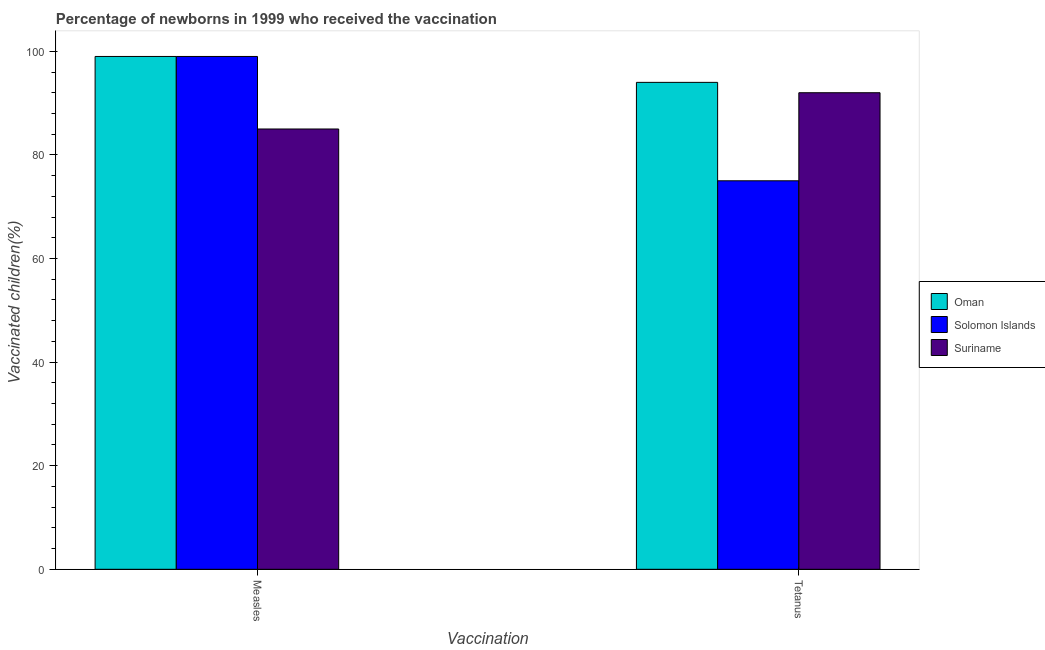How many different coloured bars are there?
Make the answer very short. 3. Are the number of bars on each tick of the X-axis equal?
Give a very brief answer. Yes. How many bars are there on the 2nd tick from the right?
Give a very brief answer. 3. What is the label of the 2nd group of bars from the left?
Make the answer very short. Tetanus. What is the percentage of newborns who received vaccination for tetanus in Oman?
Provide a succinct answer. 94. Across all countries, what is the maximum percentage of newborns who received vaccination for measles?
Provide a short and direct response. 99. Across all countries, what is the minimum percentage of newborns who received vaccination for tetanus?
Offer a very short reply. 75. In which country was the percentage of newborns who received vaccination for measles maximum?
Your answer should be very brief. Oman. In which country was the percentage of newborns who received vaccination for tetanus minimum?
Offer a terse response. Solomon Islands. What is the total percentage of newborns who received vaccination for tetanus in the graph?
Your answer should be compact. 261. What is the difference between the percentage of newborns who received vaccination for tetanus in Suriname and that in Oman?
Your answer should be very brief. -2. What is the difference between the percentage of newborns who received vaccination for tetanus in Oman and the percentage of newborns who received vaccination for measles in Solomon Islands?
Offer a very short reply. -5. What is the average percentage of newborns who received vaccination for measles per country?
Your response must be concise. 94.33. What is the difference between the percentage of newborns who received vaccination for measles and percentage of newborns who received vaccination for tetanus in Solomon Islands?
Make the answer very short. 24. In how many countries, is the percentage of newborns who received vaccination for tetanus greater than 16 %?
Your answer should be compact. 3. What is the ratio of the percentage of newborns who received vaccination for tetanus in Oman to that in Solomon Islands?
Give a very brief answer. 1.25. What does the 2nd bar from the left in Measles represents?
Ensure brevity in your answer.  Solomon Islands. What does the 3rd bar from the right in Tetanus represents?
Your answer should be compact. Oman. Are all the bars in the graph horizontal?
Ensure brevity in your answer.  No. How many countries are there in the graph?
Give a very brief answer. 3. What is the difference between two consecutive major ticks on the Y-axis?
Your answer should be compact. 20. Does the graph contain any zero values?
Your answer should be very brief. No. How many legend labels are there?
Ensure brevity in your answer.  3. How are the legend labels stacked?
Make the answer very short. Vertical. What is the title of the graph?
Provide a succinct answer. Percentage of newborns in 1999 who received the vaccination. What is the label or title of the X-axis?
Provide a short and direct response. Vaccination. What is the label or title of the Y-axis?
Your response must be concise. Vaccinated children(%)
. What is the Vaccinated children(%)
 in Oman in Measles?
Make the answer very short. 99. What is the Vaccinated children(%)
 of Solomon Islands in Measles?
Offer a very short reply. 99. What is the Vaccinated children(%)
 in Oman in Tetanus?
Your answer should be very brief. 94. What is the Vaccinated children(%)
 of Suriname in Tetanus?
Offer a terse response. 92. Across all Vaccination, what is the maximum Vaccinated children(%)
 in Oman?
Give a very brief answer. 99. Across all Vaccination, what is the maximum Vaccinated children(%)
 in Solomon Islands?
Your answer should be compact. 99. Across all Vaccination, what is the maximum Vaccinated children(%)
 in Suriname?
Your answer should be compact. 92. Across all Vaccination, what is the minimum Vaccinated children(%)
 of Oman?
Ensure brevity in your answer.  94. Across all Vaccination, what is the minimum Vaccinated children(%)
 in Suriname?
Your answer should be compact. 85. What is the total Vaccinated children(%)
 of Oman in the graph?
Your answer should be very brief. 193. What is the total Vaccinated children(%)
 of Solomon Islands in the graph?
Ensure brevity in your answer.  174. What is the total Vaccinated children(%)
 of Suriname in the graph?
Provide a short and direct response. 177. What is the difference between the Vaccinated children(%)
 in Suriname in Measles and that in Tetanus?
Provide a succinct answer. -7. What is the difference between the Vaccinated children(%)
 in Oman in Measles and the Vaccinated children(%)
 in Suriname in Tetanus?
Provide a succinct answer. 7. What is the difference between the Vaccinated children(%)
 in Solomon Islands in Measles and the Vaccinated children(%)
 in Suriname in Tetanus?
Your response must be concise. 7. What is the average Vaccinated children(%)
 of Oman per Vaccination?
Provide a succinct answer. 96.5. What is the average Vaccinated children(%)
 in Solomon Islands per Vaccination?
Offer a terse response. 87. What is the average Vaccinated children(%)
 of Suriname per Vaccination?
Your answer should be very brief. 88.5. What is the difference between the Vaccinated children(%)
 of Oman and Vaccinated children(%)
 of Solomon Islands in Measles?
Give a very brief answer. 0. What is the difference between the Vaccinated children(%)
 in Oman and Vaccinated children(%)
 in Suriname in Tetanus?
Your answer should be very brief. 2. What is the ratio of the Vaccinated children(%)
 of Oman in Measles to that in Tetanus?
Offer a very short reply. 1.05. What is the ratio of the Vaccinated children(%)
 of Solomon Islands in Measles to that in Tetanus?
Ensure brevity in your answer.  1.32. What is the ratio of the Vaccinated children(%)
 of Suriname in Measles to that in Tetanus?
Offer a terse response. 0.92. What is the difference between the highest and the second highest Vaccinated children(%)
 in Solomon Islands?
Your answer should be very brief. 24. What is the difference between the highest and the second highest Vaccinated children(%)
 in Suriname?
Provide a short and direct response. 7. What is the difference between the highest and the lowest Vaccinated children(%)
 in Oman?
Your answer should be very brief. 5. What is the difference between the highest and the lowest Vaccinated children(%)
 of Solomon Islands?
Your answer should be very brief. 24. What is the difference between the highest and the lowest Vaccinated children(%)
 in Suriname?
Provide a short and direct response. 7. 